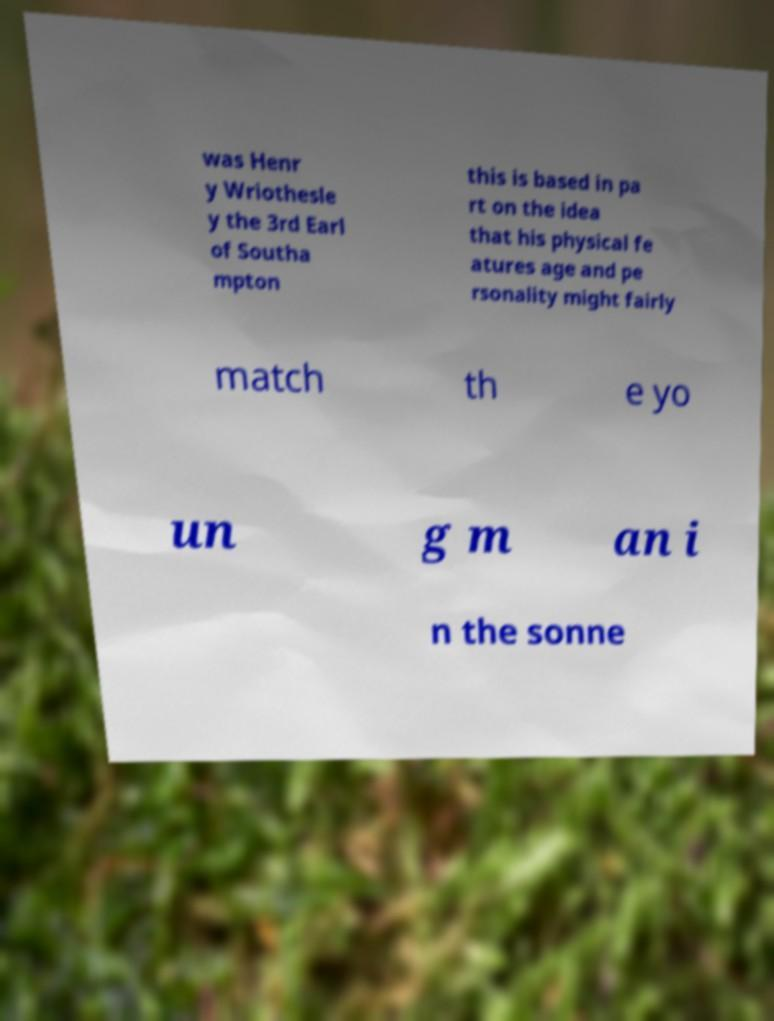Can you read and provide the text displayed in the image?This photo seems to have some interesting text. Can you extract and type it out for me? was Henr y Wriothesle y the 3rd Earl of Southa mpton this is based in pa rt on the idea that his physical fe atures age and pe rsonality might fairly match th e yo un g m an i n the sonne 